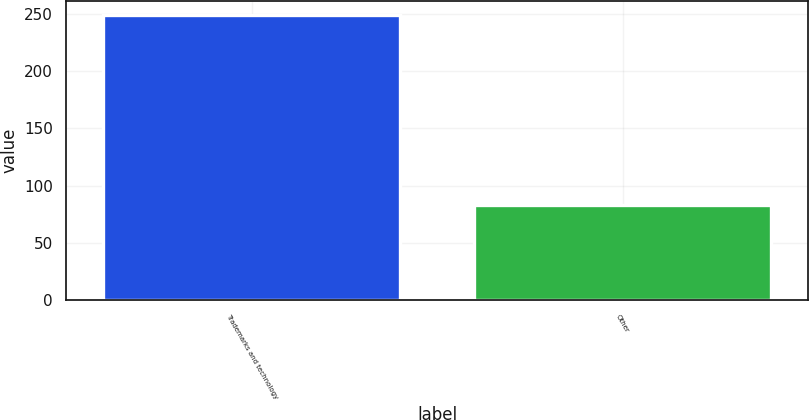<chart> <loc_0><loc_0><loc_500><loc_500><bar_chart><fcel>Trademarks and technology<fcel>Other<nl><fcel>249<fcel>83<nl></chart> 